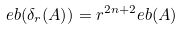<formula> <loc_0><loc_0><loc_500><loc_500>\L e b ( \delta _ { r } ( A ) ) = r ^ { 2 n + 2 } \L e b ( A )</formula> 